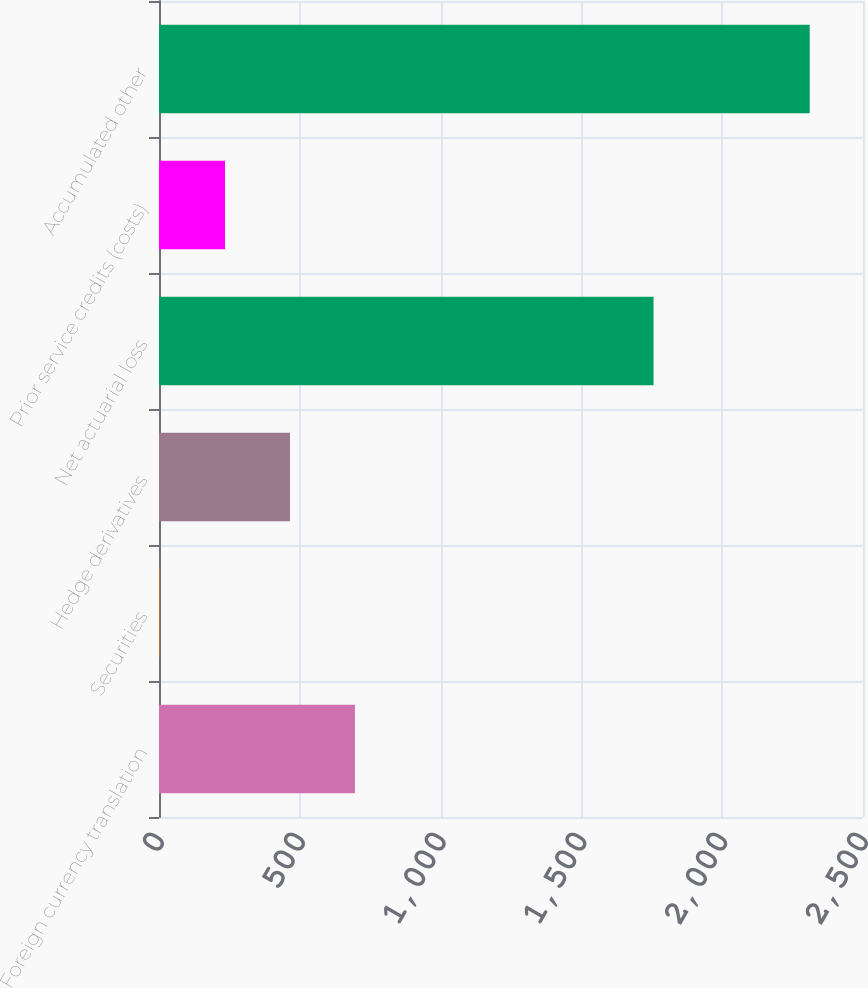<chart> <loc_0><loc_0><loc_500><loc_500><bar_chart><fcel>Foreign currency translation<fcel>Securities<fcel>Hedge derivatives<fcel>Net actuarial loss<fcel>Prior service credits (costs)<fcel>Accumulated other<nl><fcel>695.8<fcel>3.7<fcel>465.1<fcel>1756.1<fcel>234.4<fcel>2310.7<nl></chart> 